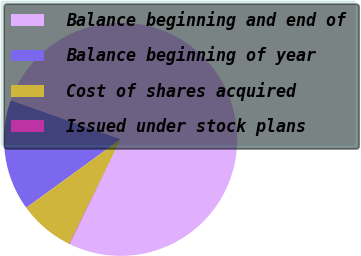<chart> <loc_0><loc_0><loc_500><loc_500><pie_chart><fcel>Balance beginning and end of<fcel>Balance beginning of year<fcel>Cost of shares acquired<fcel>Issued under stock plans<nl><fcel>76.77%<fcel>15.41%<fcel>7.74%<fcel>0.07%<nl></chart> 